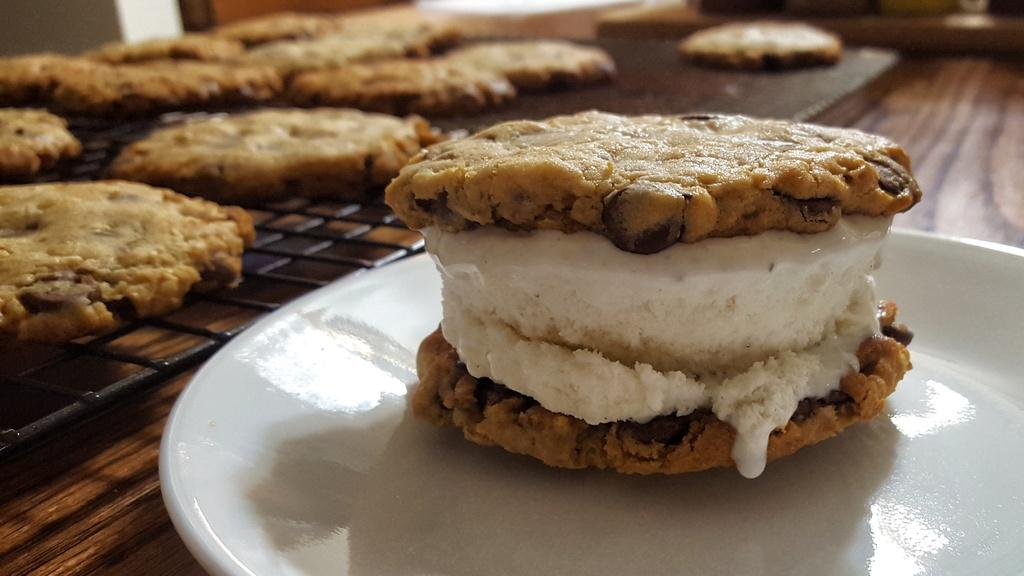What type of dessert is on a plate in the image? There is a cake on a plate in the image. What other type of dessert can be seen in the image? There are cookies on grills in the image. What type of lace is draped over the cake in the image? There is no lace present in the image; it only shows a cake on a plate and cookies on grills. grills. 